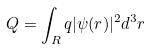Convert formula to latex. <formula><loc_0><loc_0><loc_500><loc_500>Q = \int _ { R } q | \psi ( r ) | ^ { 2 } d ^ { 3 } r</formula> 